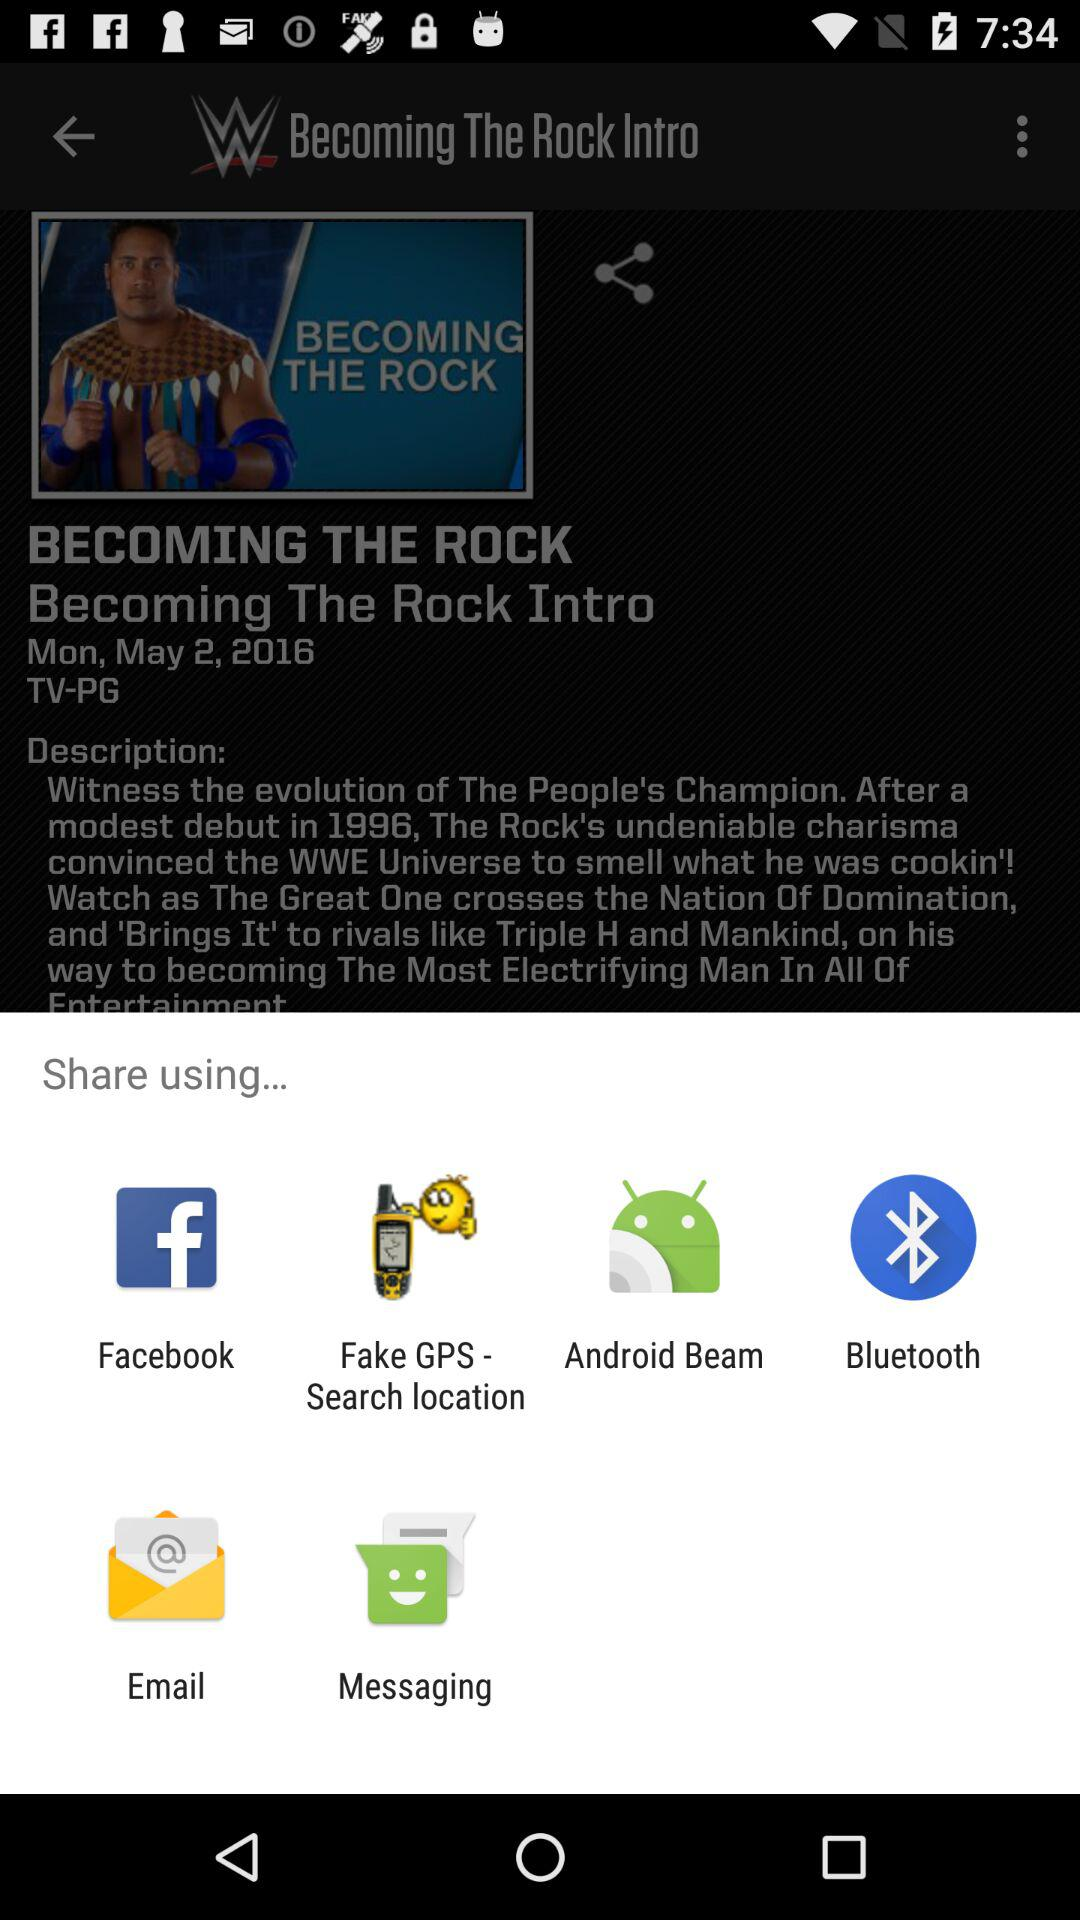What is the movie name? The movie name is "BECOMING THE ROCK". 